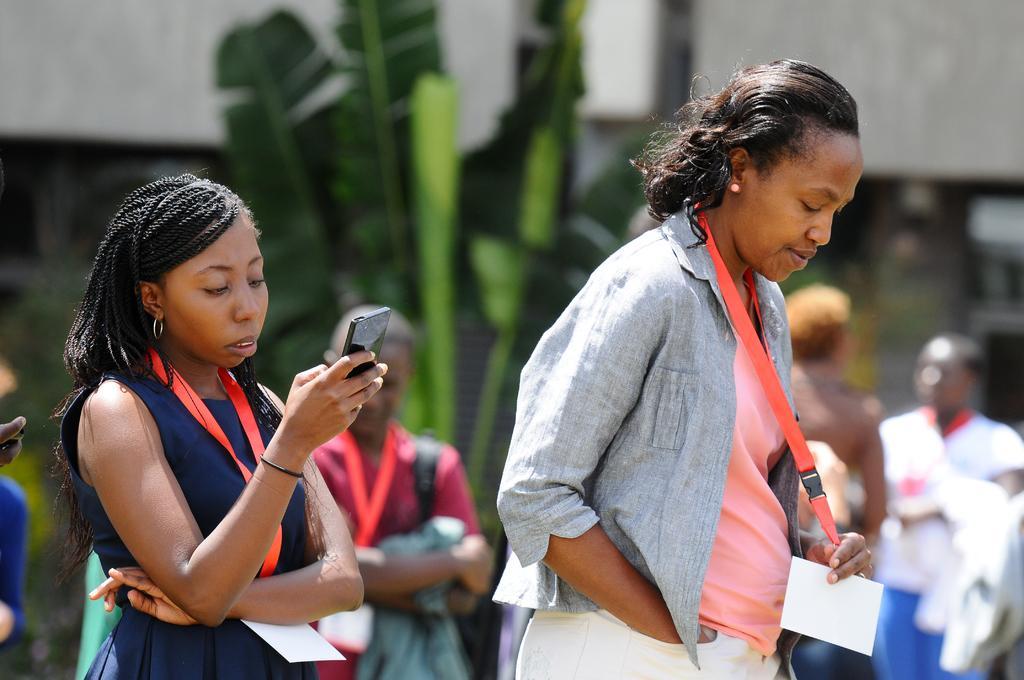In one or two sentences, can you explain what this image depicts? In this image, we can see two women are standing. Here a woman is holding a tag with card. On the left side of the image, woman is holding a mobile. Background there is a blur view. Here we can see tree, wall and few people. 